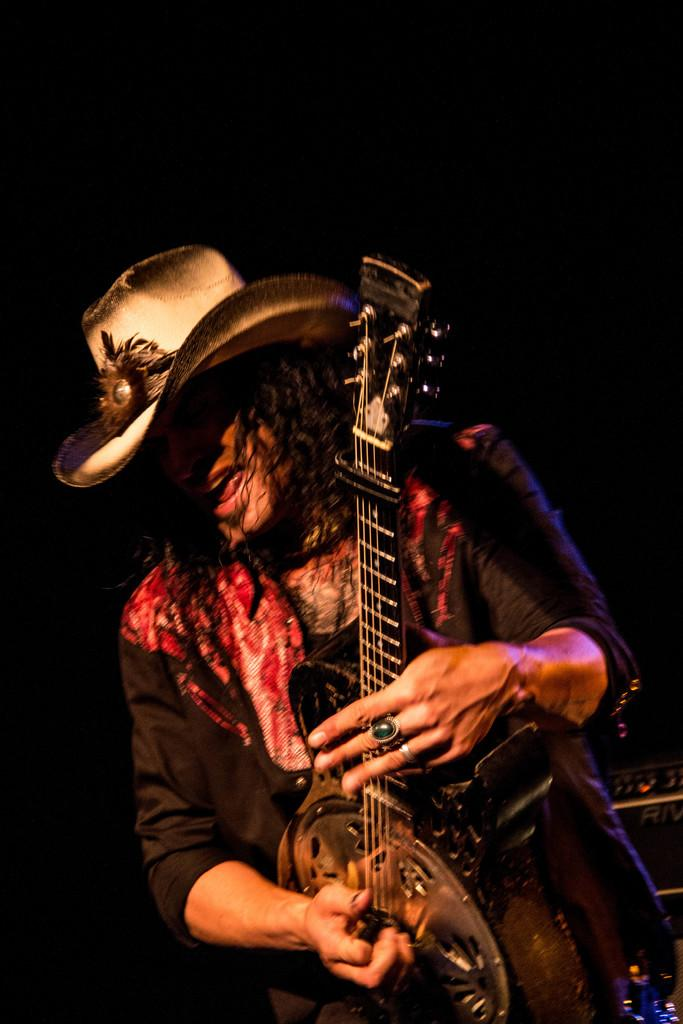What is the main subject of the image? There is a man in the image. What is the man wearing on his head? The man is wearing a cap. What is the man doing in the image? The man is playing a guitar. What color is the background of the image? The background of the image is black. What type of rod can be seen in the man's hand in the image? There is no rod present in the man's hand in the image; he is holding a guitar. What scientific discovery is the man making in the image? There is no indication of a scientific discovery being made in the image; the man is simply playing a guitar. 